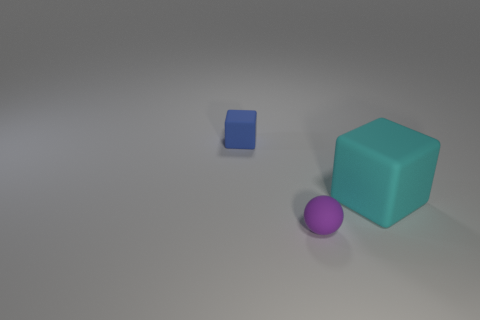Add 2 blocks. How many objects exist? 5 Subtract all cubes. How many objects are left? 1 Subtract all small objects. Subtract all blue matte cubes. How many objects are left? 0 Add 2 big objects. How many big objects are left? 3 Add 2 tiny red spheres. How many tiny red spheres exist? 2 Subtract 1 cyan cubes. How many objects are left? 2 